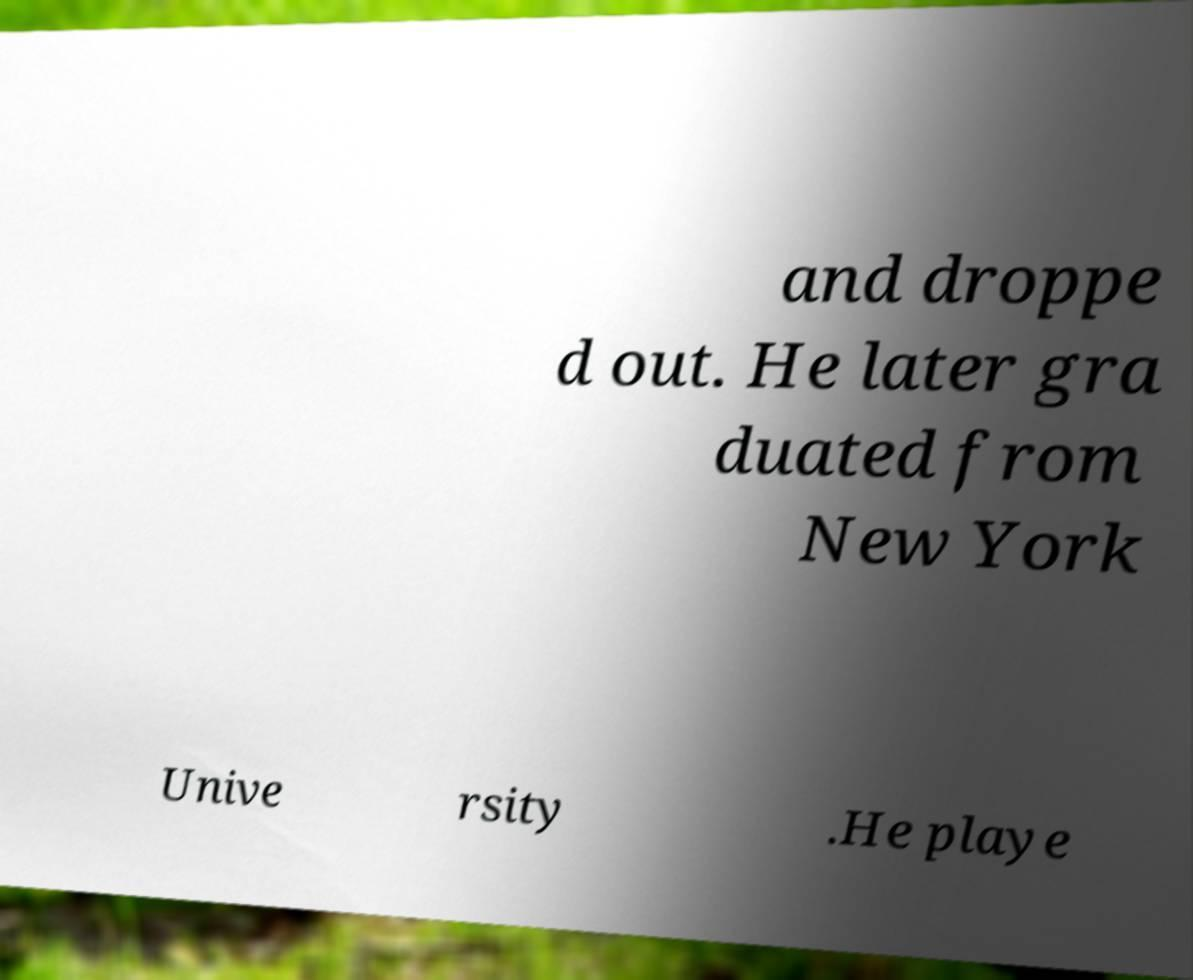Please identify and transcribe the text found in this image. and droppe d out. He later gra duated from New York Unive rsity .He playe 